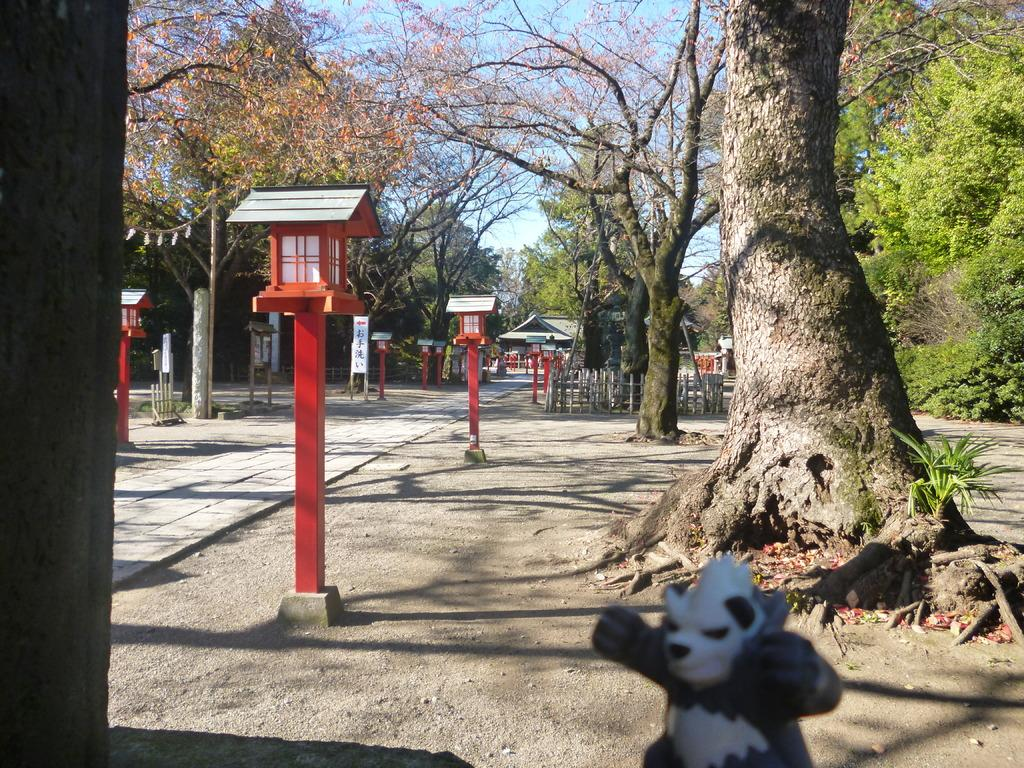What object is located at the bottom of the image? There is a toy at the bottom of the image. What can be seen in the background of the image? There are trees, poles, a roof, a house, fences, and clouds in the sky in the background of the image. What type of music can be heard coming from the toy in the image? There is no indication in the image that the toy is making any sounds, let alone music. 